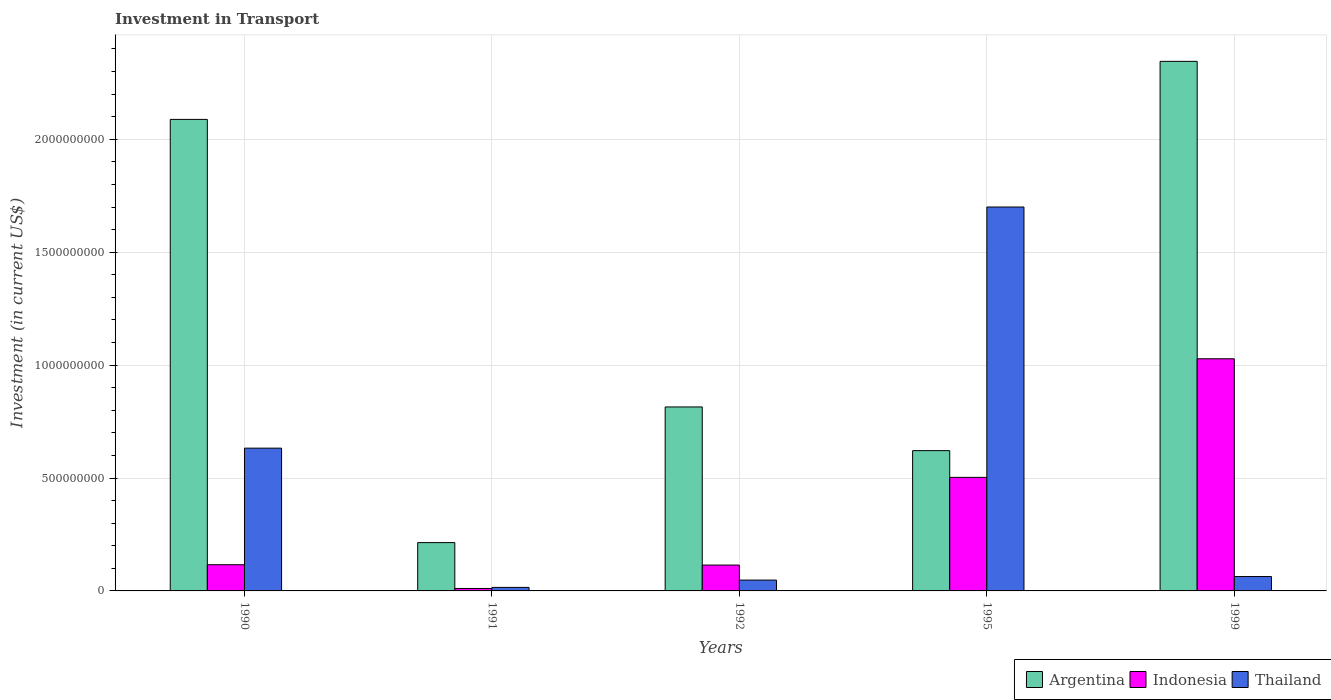How many different coloured bars are there?
Offer a very short reply. 3. How many groups of bars are there?
Your answer should be very brief. 5. How many bars are there on the 5th tick from the left?
Ensure brevity in your answer.  3. What is the label of the 5th group of bars from the left?
Offer a terse response. 1999. What is the amount invested in transport in Indonesia in 1995?
Your answer should be compact. 5.03e+08. Across all years, what is the maximum amount invested in transport in Thailand?
Your answer should be very brief. 1.70e+09. Across all years, what is the minimum amount invested in transport in Indonesia?
Provide a short and direct response. 1.08e+07. In which year was the amount invested in transport in Argentina maximum?
Your answer should be compact. 1999. What is the total amount invested in transport in Indonesia in the graph?
Your answer should be compact. 1.77e+09. What is the difference between the amount invested in transport in Indonesia in 1992 and that in 1999?
Provide a succinct answer. -9.14e+08. What is the difference between the amount invested in transport in Indonesia in 1991 and the amount invested in transport in Argentina in 1990?
Your answer should be compact. -2.08e+09. What is the average amount invested in transport in Thailand per year?
Keep it short and to the point. 4.92e+08. In the year 1999, what is the difference between the amount invested in transport in Indonesia and amount invested in transport in Thailand?
Give a very brief answer. 9.64e+08. What is the ratio of the amount invested in transport in Thailand in 1995 to that in 1999?
Provide a short and direct response. 26.68. Is the amount invested in transport in Argentina in 1995 less than that in 1999?
Make the answer very short. Yes. Is the difference between the amount invested in transport in Indonesia in 1991 and 1999 greater than the difference between the amount invested in transport in Thailand in 1991 and 1999?
Your answer should be very brief. No. What is the difference between the highest and the second highest amount invested in transport in Indonesia?
Offer a very short reply. 5.25e+08. What is the difference between the highest and the lowest amount invested in transport in Thailand?
Keep it short and to the point. 1.68e+09. In how many years, is the amount invested in transport in Argentina greater than the average amount invested in transport in Argentina taken over all years?
Give a very brief answer. 2. What does the 3rd bar from the left in 1992 represents?
Your answer should be compact. Thailand. What does the 2nd bar from the right in 1999 represents?
Offer a very short reply. Indonesia. Is it the case that in every year, the sum of the amount invested in transport in Thailand and amount invested in transport in Argentina is greater than the amount invested in transport in Indonesia?
Keep it short and to the point. Yes. How many bars are there?
Keep it short and to the point. 15. Are all the bars in the graph horizontal?
Offer a very short reply. No. How many years are there in the graph?
Ensure brevity in your answer.  5. What is the difference between two consecutive major ticks on the Y-axis?
Your answer should be very brief. 5.00e+08. Does the graph contain any zero values?
Your answer should be compact. No. Does the graph contain grids?
Provide a succinct answer. Yes. Where does the legend appear in the graph?
Provide a short and direct response. Bottom right. How many legend labels are there?
Your response must be concise. 3. How are the legend labels stacked?
Ensure brevity in your answer.  Horizontal. What is the title of the graph?
Give a very brief answer. Investment in Transport. What is the label or title of the Y-axis?
Give a very brief answer. Investment (in current US$). What is the Investment (in current US$) of Argentina in 1990?
Offer a very short reply. 2.09e+09. What is the Investment (in current US$) of Indonesia in 1990?
Offer a very short reply. 1.16e+08. What is the Investment (in current US$) in Thailand in 1990?
Keep it short and to the point. 6.32e+08. What is the Investment (in current US$) in Argentina in 1991?
Ensure brevity in your answer.  2.14e+08. What is the Investment (in current US$) in Indonesia in 1991?
Offer a terse response. 1.08e+07. What is the Investment (in current US$) in Thailand in 1991?
Your response must be concise. 1.57e+07. What is the Investment (in current US$) in Argentina in 1992?
Keep it short and to the point. 8.15e+08. What is the Investment (in current US$) in Indonesia in 1992?
Provide a succinct answer. 1.14e+08. What is the Investment (in current US$) of Thailand in 1992?
Provide a succinct answer. 4.80e+07. What is the Investment (in current US$) of Argentina in 1995?
Provide a short and direct response. 6.21e+08. What is the Investment (in current US$) of Indonesia in 1995?
Make the answer very short. 5.03e+08. What is the Investment (in current US$) of Thailand in 1995?
Offer a terse response. 1.70e+09. What is the Investment (in current US$) of Argentina in 1999?
Your answer should be compact. 2.34e+09. What is the Investment (in current US$) of Indonesia in 1999?
Your answer should be compact. 1.03e+09. What is the Investment (in current US$) in Thailand in 1999?
Make the answer very short. 6.37e+07. Across all years, what is the maximum Investment (in current US$) in Argentina?
Ensure brevity in your answer.  2.34e+09. Across all years, what is the maximum Investment (in current US$) in Indonesia?
Keep it short and to the point. 1.03e+09. Across all years, what is the maximum Investment (in current US$) of Thailand?
Offer a terse response. 1.70e+09. Across all years, what is the minimum Investment (in current US$) of Argentina?
Your response must be concise. 2.14e+08. Across all years, what is the minimum Investment (in current US$) in Indonesia?
Ensure brevity in your answer.  1.08e+07. Across all years, what is the minimum Investment (in current US$) of Thailand?
Your answer should be compact. 1.57e+07. What is the total Investment (in current US$) in Argentina in the graph?
Make the answer very short. 6.08e+09. What is the total Investment (in current US$) in Indonesia in the graph?
Offer a terse response. 1.77e+09. What is the total Investment (in current US$) in Thailand in the graph?
Provide a succinct answer. 2.46e+09. What is the difference between the Investment (in current US$) of Argentina in 1990 and that in 1991?
Provide a short and direct response. 1.87e+09. What is the difference between the Investment (in current US$) of Indonesia in 1990 and that in 1991?
Offer a terse response. 1.05e+08. What is the difference between the Investment (in current US$) of Thailand in 1990 and that in 1991?
Give a very brief answer. 6.16e+08. What is the difference between the Investment (in current US$) in Argentina in 1990 and that in 1992?
Provide a short and direct response. 1.27e+09. What is the difference between the Investment (in current US$) of Indonesia in 1990 and that in 1992?
Ensure brevity in your answer.  1.50e+06. What is the difference between the Investment (in current US$) of Thailand in 1990 and that in 1992?
Offer a terse response. 5.84e+08. What is the difference between the Investment (in current US$) of Argentina in 1990 and that in 1995?
Ensure brevity in your answer.  1.47e+09. What is the difference between the Investment (in current US$) in Indonesia in 1990 and that in 1995?
Make the answer very short. -3.87e+08. What is the difference between the Investment (in current US$) in Thailand in 1990 and that in 1995?
Offer a very short reply. -1.07e+09. What is the difference between the Investment (in current US$) in Argentina in 1990 and that in 1999?
Keep it short and to the point. -2.57e+08. What is the difference between the Investment (in current US$) in Indonesia in 1990 and that in 1999?
Your answer should be very brief. -9.12e+08. What is the difference between the Investment (in current US$) in Thailand in 1990 and that in 1999?
Give a very brief answer. 5.68e+08. What is the difference between the Investment (in current US$) in Argentina in 1991 and that in 1992?
Ensure brevity in your answer.  -6.01e+08. What is the difference between the Investment (in current US$) of Indonesia in 1991 and that in 1992?
Give a very brief answer. -1.04e+08. What is the difference between the Investment (in current US$) of Thailand in 1991 and that in 1992?
Offer a very short reply. -3.23e+07. What is the difference between the Investment (in current US$) in Argentina in 1991 and that in 1995?
Offer a terse response. -4.07e+08. What is the difference between the Investment (in current US$) in Indonesia in 1991 and that in 1995?
Your answer should be very brief. -4.92e+08. What is the difference between the Investment (in current US$) in Thailand in 1991 and that in 1995?
Provide a succinct answer. -1.68e+09. What is the difference between the Investment (in current US$) of Argentina in 1991 and that in 1999?
Give a very brief answer. -2.13e+09. What is the difference between the Investment (in current US$) of Indonesia in 1991 and that in 1999?
Your response must be concise. -1.02e+09. What is the difference between the Investment (in current US$) in Thailand in 1991 and that in 1999?
Ensure brevity in your answer.  -4.80e+07. What is the difference between the Investment (in current US$) of Argentina in 1992 and that in 1995?
Make the answer very short. 1.94e+08. What is the difference between the Investment (in current US$) in Indonesia in 1992 and that in 1995?
Your response must be concise. -3.88e+08. What is the difference between the Investment (in current US$) of Thailand in 1992 and that in 1995?
Offer a very short reply. -1.65e+09. What is the difference between the Investment (in current US$) in Argentina in 1992 and that in 1999?
Your answer should be very brief. -1.53e+09. What is the difference between the Investment (in current US$) in Indonesia in 1992 and that in 1999?
Make the answer very short. -9.14e+08. What is the difference between the Investment (in current US$) in Thailand in 1992 and that in 1999?
Your answer should be very brief. -1.57e+07. What is the difference between the Investment (in current US$) in Argentina in 1995 and that in 1999?
Offer a terse response. -1.72e+09. What is the difference between the Investment (in current US$) of Indonesia in 1995 and that in 1999?
Provide a succinct answer. -5.25e+08. What is the difference between the Investment (in current US$) of Thailand in 1995 and that in 1999?
Make the answer very short. 1.64e+09. What is the difference between the Investment (in current US$) of Argentina in 1990 and the Investment (in current US$) of Indonesia in 1991?
Your response must be concise. 2.08e+09. What is the difference between the Investment (in current US$) of Argentina in 1990 and the Investment (in current US$) of Thailand in 1991?
Your answer should be compact. 2.07e+09. What is the difference between the Investment (in current US$) of Indonesia in 1990 and the Investment (in current US$) of Thailand in 1991?
Make the answer very short. 1.00e+08. What is the difference between the Investment (in current US$) in Argentina in 1990 and the Investment (in current US$) in Indonesia in 1992?
Keep it short and to the point. 1.97e+09. What is the difference between the Investment (in current US$) of Argentina in 1990 and the Investment (in current US$) of Thailand in 1992?
Your answer should be very brief. 2.04e+09. What is the difference between the Investment (in current US$) in Indonesia in 1990 and the Investment (in current US$) in Thailand in 1992?
Offer a very short reply. 6.80e+07. What is the difference between the Investment (in current US$) in Argentina in 1990 and the Investment (in current US$) in Indonesia in 1995?
Your response must be concise. 1.59e+09. What is the difference between the Investment (in current US$) in Argentina in 1990 and the Investment (in current US$) in Thailand in 1995?
Ensure brevity in your answer.  3.88e+08. What is the difference between the Investment (in current US$) in Indonesia in 1990 and the Investment (in current US$) in Thailand in 1995?
Your answer should be compact. -1.58e+09. What is the difference between the Investment (in current US$) of Argentina in 1990 and the Investment (in current US$) of Indonesia in 1999?
Provide a short and direct response. 1.06e+09. What is the difference between the Investment (in current US$) of Argentina in 1990 and the Investment (in current US$) of Thailand in 1999?
Your response must be concise. 2.02e+09. What is the difference between the Investment (in current US$) in Indonesia in 1990 and the Investment (in current US$) in Thailand in 1999?
Offer a terse response. 5.23e+07. What is the difference between the Investment (in current US$) in Argentina in 1991 and the Investment (in current US$) in Indonesia in 1992?
Offer a very short reply. 9.95e+07. What is the difference between the Investment (in current US$) of Argentina in 1991 and the Investment (in current US$) of Thailand in 1992?
Offer a very short reply. 1.66e+08. What is the difference between the Investment (in current US$) of Indonesia in 1991 and the Investment (in current US$) of Thailand in 1992?
Provide a short and direct response. -3.72e+07. What is the difference between the Investment (in current US$) of Argentina in 1991 and the Investment (in current US$) of Indonesia in 1995?
Offer a very short reply. -2.89e+08. What is the difference between the Investment (in current US$) in Argentina in 1991 and the Investment (in current US$) in Thailand in 1995?
Offer a very short reply. -1.49e+09. What is the difference between the Investment (in current US$) in Indonesia in 1991 and the Investment (in current US$) in Thailand in 1995?
Your response must be concise. -1.69e+09. What is the difference between the Investment (in current US$) in Argentina in 1991 and the Investment (in current US$) in Indonesia in 1999?
Your response must be concise. -8.14e+08. What is the difference between the Investment (in current US$) in Argentina in 1991 and the Investment (in current US$) in Thailand in 1999?
Provide a short and direct response. 1.50e+08. What is the difference between the Investment (in current US$) in Indonesia in 1991 and the Investment (in current US$) in Thailand in 1999?
Your answer should be compact. -5.29e+07. What is the difference between the Investment (in current US$) of Argentina in 1992 and the Investment (in current US$) of Indonesia in 1995?
Your response must be concise. 3.12e+08. What is the difference between the Investment (in current US$) of Argentina in 1992 and the Investment (in current US$) of Thailand in 1995?
Your answer should be compact. -8.85e+08. What is the difference between the Investment (in current US$) of Indonesia in 1992 and the Investment (in current US$) of Thailand in 1995?
Offer a very short reply. -1.59e+09. What is the difference between the Investment (in current US$) of Argentina in 1992 and the Investment (in current US$) of Indonesia in 1999?
Ensure brevity in your answer.  -2.13e+08. What is the difference between the Investment (in current US$) in Argentina in 1992 and the Investment (in current US$) in Thailand in 1999?
Your answer should be compact. 7.51e+08. What is the difference between the Investment (in current US$) of Indonesia in 1992 and the Investment (in current US$) of Thailand in 1999?
Your answer should be compact. 5.08e+07. What is the difference between the Investment (in current US$) of Argentina in 1995 and the Investment (in current US$) of Indonesia in 1999?
Provide a succinct answer. -4.07e+08. What is the difference between the Investment (in current US$) of Argentina in 1995 and the Investment (in current US$) of Thailand in 1999?
Provide a short and direct response. 5.57e+08. What is the difference between the Investment (in current US$) in Indonesia in 1995 and the Investment (in current US$) in Thailand in 1999?
Offer a very short reply. 4.39e+08. What is the average Investment (in current US$) of Argentina per year?
Provide a succinct answer. 1.22e+09. What is the average Investment (in current US$) of Indonesia per year?
Give a very brief answer. 3.54e+08. What is the average Investment (in current US$) of Thailand per year?
Give a very brief answer. 4.92e+08. In the year 1990, what is the difference between the Investment (in current US$) of Argentina and Investment (in current US$) of Indonesia?
Give a very brief answer. 1.97e+09. In the year 1990, what is the difference between the Investment (in current US$) in Argentina and Investment (in current US$) in Thailand?
Provide a succinct answer. 1.46e+09. In the year 1990, what is the difference between the Investment (in current US$) of Indonesia and Investment (in current US$) of Thailand?
Keep it short and to the point. -5.16e+08. In the year 1991, what is the difference between the Investment (in current US$) of Argentina and Investment (in current US$) of Indonesia?
Your answer should be compact. 2.03e+08. In the year 1991, what is the difference between the Investment (in current US$) of Argentina and Investment (in current US$) of Thailand?
Your answer should be compact. 1.98e+08. In the year 1991, what is the difference between the Investment (in current US$) of Indonesia and Investment (in current US$) of Thailand?
Ensure brevity in your answer.  -4.90e+06. In the year 1992, what is the difference between the Investment (in current US$) of Argentina and Investment (in current US$) of Indonesia?
Ensure brevity in your answer.  7.00e+08. In the year 1992, what is the difference between the Investment (in current US$) in Argentina and Investment (in current US$) in Thailand?
Offer a terse response. 7.67e+08. In the year 1992, what is the difference between the Investment (in current US$) of Indonesia and Investment (in current US$) of Thailand?
Your answer should be compact. 6.65e+07. In the year 1995, what is the difference between the Investment (in current US$) of Argentina and Investment (in current US$) of Indonesia?
Provide a succinct answer. 1.18e+08. In the year 1995, what is the difference between the Investment (in current US$) in Argentina and Investment (in current US$) in Thailand?
Give a very brief answer. -1.08e+09. In the year 1995, what is the difference between the Investment (in current US$) in Indonesia and Investment (in current US$) in Thailand?
Keep it short and to the point. -1.20e+09. In the year 1999, what is the difference between the Investment (in current US$) in Argentina and Investment (in current US$) in Indonesia?
Your answer should be very brief. 1.32e+09. In the year 1999, what is the difference between the Investment (in current US$) of Argentina and Investment (in current US$) of Thailand?
Your response must be concise. 2.28e+09. In the year 1999, what is the difference between the Investment (in current US$) in Indonesia and Investment (in current US$) in Thailand?
Your answer should be very brief. 9.64e+08. What is the ratio of the Investment (in current US$) of Argentina in 1990 to that in 1991?
Your answer should be compact. 9.76. What is the ratio of the Investment (in current US$) of Indonesia in 1990 to that in 1991?
Give a very brief answer. 10.74. What is the ratio of the Investment (in current US$) of Thailand in 1990 to that in 1991?
Make the answer very short. 40.27. What is the ratio of the Investment (in current US$) in Argentina in 1990 to that in 1992?
Make the answer very short. 2.56. What is the ratio of the Investment (in current US$) of Indonesia in 1990 to that in 1992?
Keep it short and to the point. 1.01. What is the ratio of the Investment (in current US$) in Thailand in 1990 to that in 1992?
Offer a terse response. 13.17. What is the ratio of the Investment (in current US$) in Argentina in 1990 to that in 1995?
Provide a short and direct response. 3.36. What is the ratio of the Investment (in current US$) of Indonesia in 1990 to that in 1995?
Offer a very short reply. 0.23. What is the ratio of the Investment (in current US$) in Thailand in 1990 to that in 1995?
Keep it short and to the point. 0.37. What is the ratio of the Investment (in current US$) of Argentina in 1990 to that in 1999?
Your answer should be very brief. 0.89. What is the ratio of the Investment (in current US$) of Indonesia in 1990 to that in 1999?
Provide a succinct answer. 0.11. What is the ratio of the Investment (in current US$) in Thailand in 1990 to that in 1999?
Your response must be concise. 9.92. What is the ratio of the Investment (in current US$) in Argentina in 1991 to that in 1992?
Your answer should be very brief. 0.26. What is the ratio of the Investment (in current US$) of Indonesia in 1991 to that in 1992?
Offer a terse response. 0.09. What is the ratio of the Investment (in current US$) in Thailand in 1991 to that in 1992?
Provide a succinct answer. 0.33. What is the ratio of the Investment (in current US$) in Argentina in 1991 to that in 1995?
Ensure brevity in your answer.  0.34. What is the ratio of the Investment (in current US$) in Indonesia in 1991 to that in 1995?
Offer a very short reply. 0.02. What is the ratio of the Investment (in current US$) of Thailand in 1991 to that in 1995?
Keep it short and to the point. 0.01. What is the ratio of the Investment (in current US$) in Argentina in 1991 to that in 1999?
Make the answer very short. 0.09. What is the ratio of the Investment (in current US$) of Indonesia in 1991 to that in 1999?
Give a very brief answer. 0.01. What is the ratio of the Investment (in current US$) of Thailand in 1991 to that in 1999?
Your response must be concise. 0.25. What is the ratio of the Investment (in current US$) in Argentina in 1992 to that in 1995?
Your response must be concise. 1.31. What is the ratio of the Investment (in current US$) in Indonesia in 1992 to that in 1995?
Give a very brief answer. 0.23. What is the ratio of the Investment (in current US$) of Thailand in 1992 to that in 1995?
Make the answer very short. 0.03. What is the ratio of the Investment (in current US$) in Argentina in 1992 to that in 1999?
Offer a very short reply. 0.35. What is the ratio of the Investment (in current US$) of Indonesia in 1992 to that in 1999?
Your answer should be very brief. 0.11. What is the ratio of the Investment (in current US$) of Thailand in 1992 to that in 1999?
Give a very brief answer. 0.75. What is the ratio of the Investment (in current US$) in Argentina in 1995 to that in 1999?
Make the answer very short. 0.26. What is the ratio of the Investment (in current US$) in Indonesia in 1995 to that in 1999?
Your answer should be compact. 0.49. What is the ratio of the Investment (in current US$) of Thailand in 1995 to that in 1999?
Make the answer very short. 26.68. What is the difference between the highest and the second highest Investment (in current US$) in Argentina?
Provide a short and direct response. 2.57e+08. What is the difference between the highest and the second highest Investment (in current US$) of Indonesia?
Your answer should be compact. 5.25e+08. What is the difference between the highest and the second highest Investment (in current US$) of Thailand?
Your response must be concise. 1.07e+09. What is the difference between the highest and the lowest Investment (in current US$) in Argentina?
Your response must be concise. 2.13e+09. What is the difference between the highest and the lowest Investment (in current US$) in Indonesia?
Offer a terse response. 1.02e+09. What is the difference between the highest and the lowest Investment (in current US$) in Thailand?
Ensure brevity in your answer.  1.68e+09. 